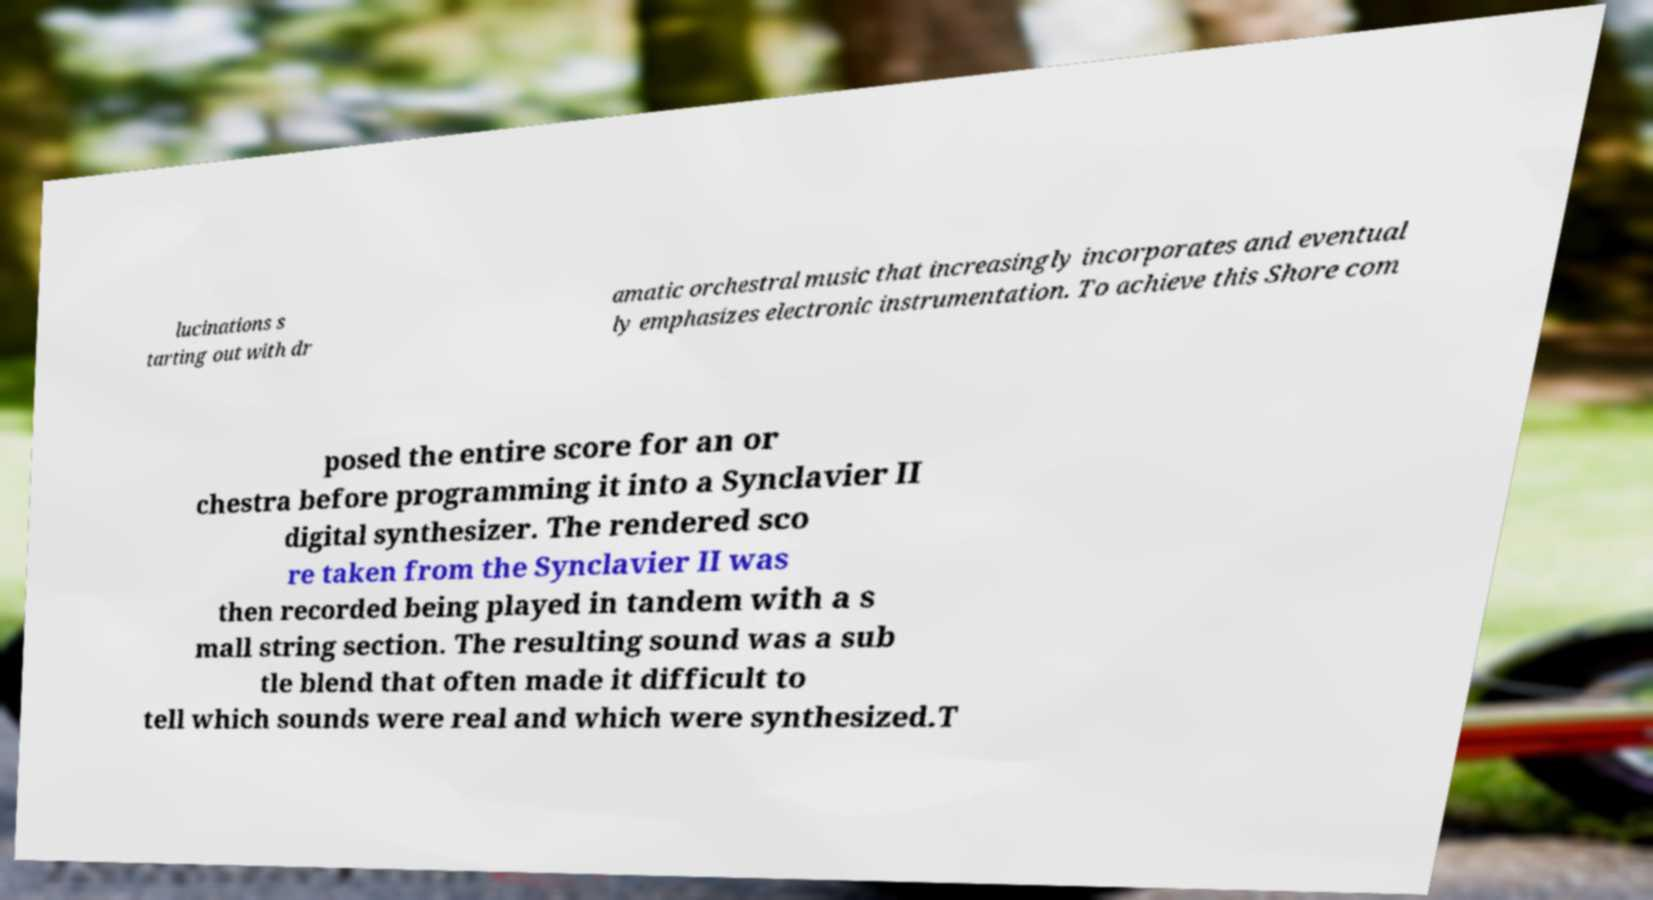I need the written content from this picture converted into text. Can you do that? lucinations s tarting out with dr amatic orchestral music that increasingly incorporates and eventual ly emphasizes electronic instrumentation. To achieve this Shore com posed the entire score for an or chestra before programming it into a Synclavier II digital synthesizer. The rendered sco re taken from the Synclavier II was then recorded being played in tandem with a s mall string section. The resulting sound was a sub tle blend that often made it difficult to tell which sounds were real and which were synthesized.T 